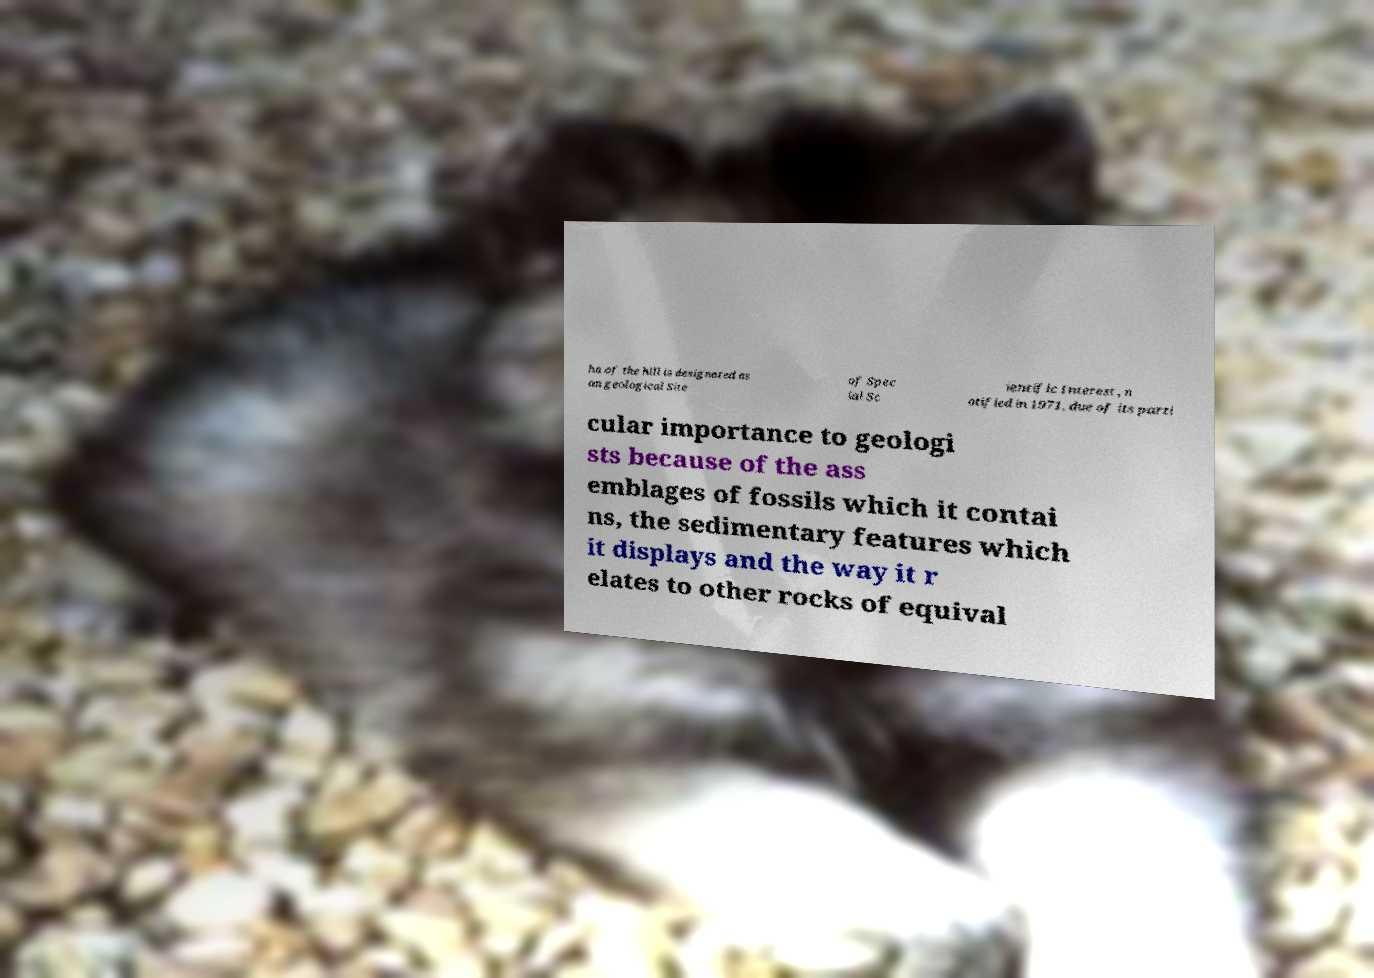I need the written content from this picture converted into text. Can you do that? ha of the hill is designated as an geological Site of Spec ial Sc ientific Interest , n otified in 1971, due of its parti cular importance to geologi sts because of the ass emblages of fossils which it contai ns, the sedimentary features which it displays and the way it r elates to other rocks of equival 